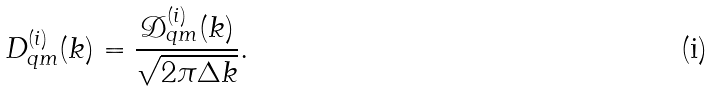<formula> <loc_0><loc_0><loc_500><loc_500>D _ { q m } ^ { ( i ) } ( k ) = \frac { \mathcal { D } _ { q m } ^ { ( i ) } ( k ) } { \sqrt { 2 \pi \Delta k } } .</formula> 